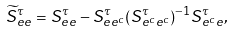<formula> <loc_0><loc_0><loc_500><loc_500>\widetilde { S } _ { e e } ^ { \tau } = S _ { e e } ^ { \tau } - S _ { e e ^ { c } } ^ { \tau } ( S _ { e ^ { c } e ^ { c } } ^ { \tau } ) ^ { - 1 } S _ { e ^ { c } e } ^ { \tau } ,</formula> 